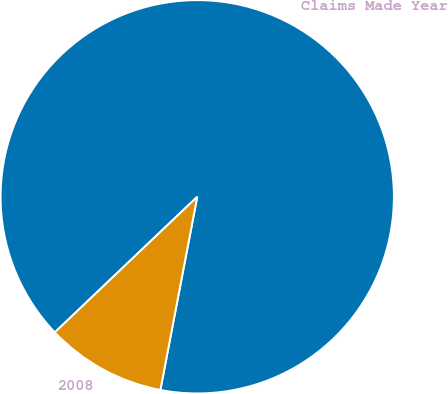Convert chart to OTSL. <chart><loc_0><loc_0><loc_500><loc_500><pie_chart><fcel>Claims Made Year<fcel>2008<nl><fcel>90.11%<fcel>9.89%<nl></chart> 